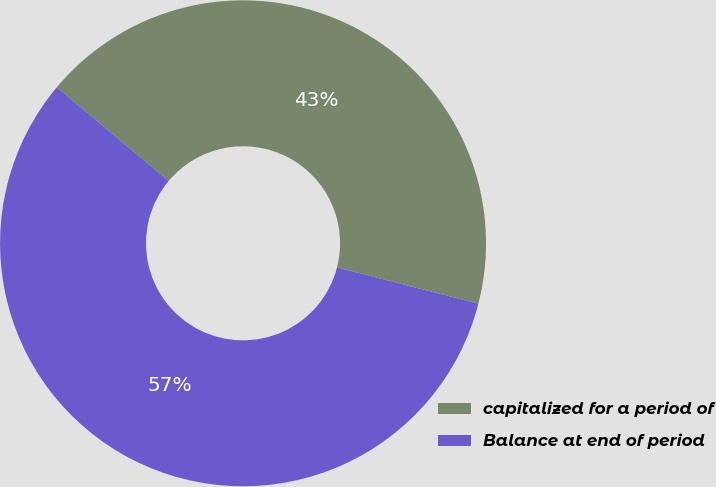<chart> <loc_0><loc_0><loc_500><loc_500><pie_chart><fcel>capitalized for a period of<fcel>Balance at end of period<nl><fcel>42.9%<fcel>57.1%<nl></chart> 